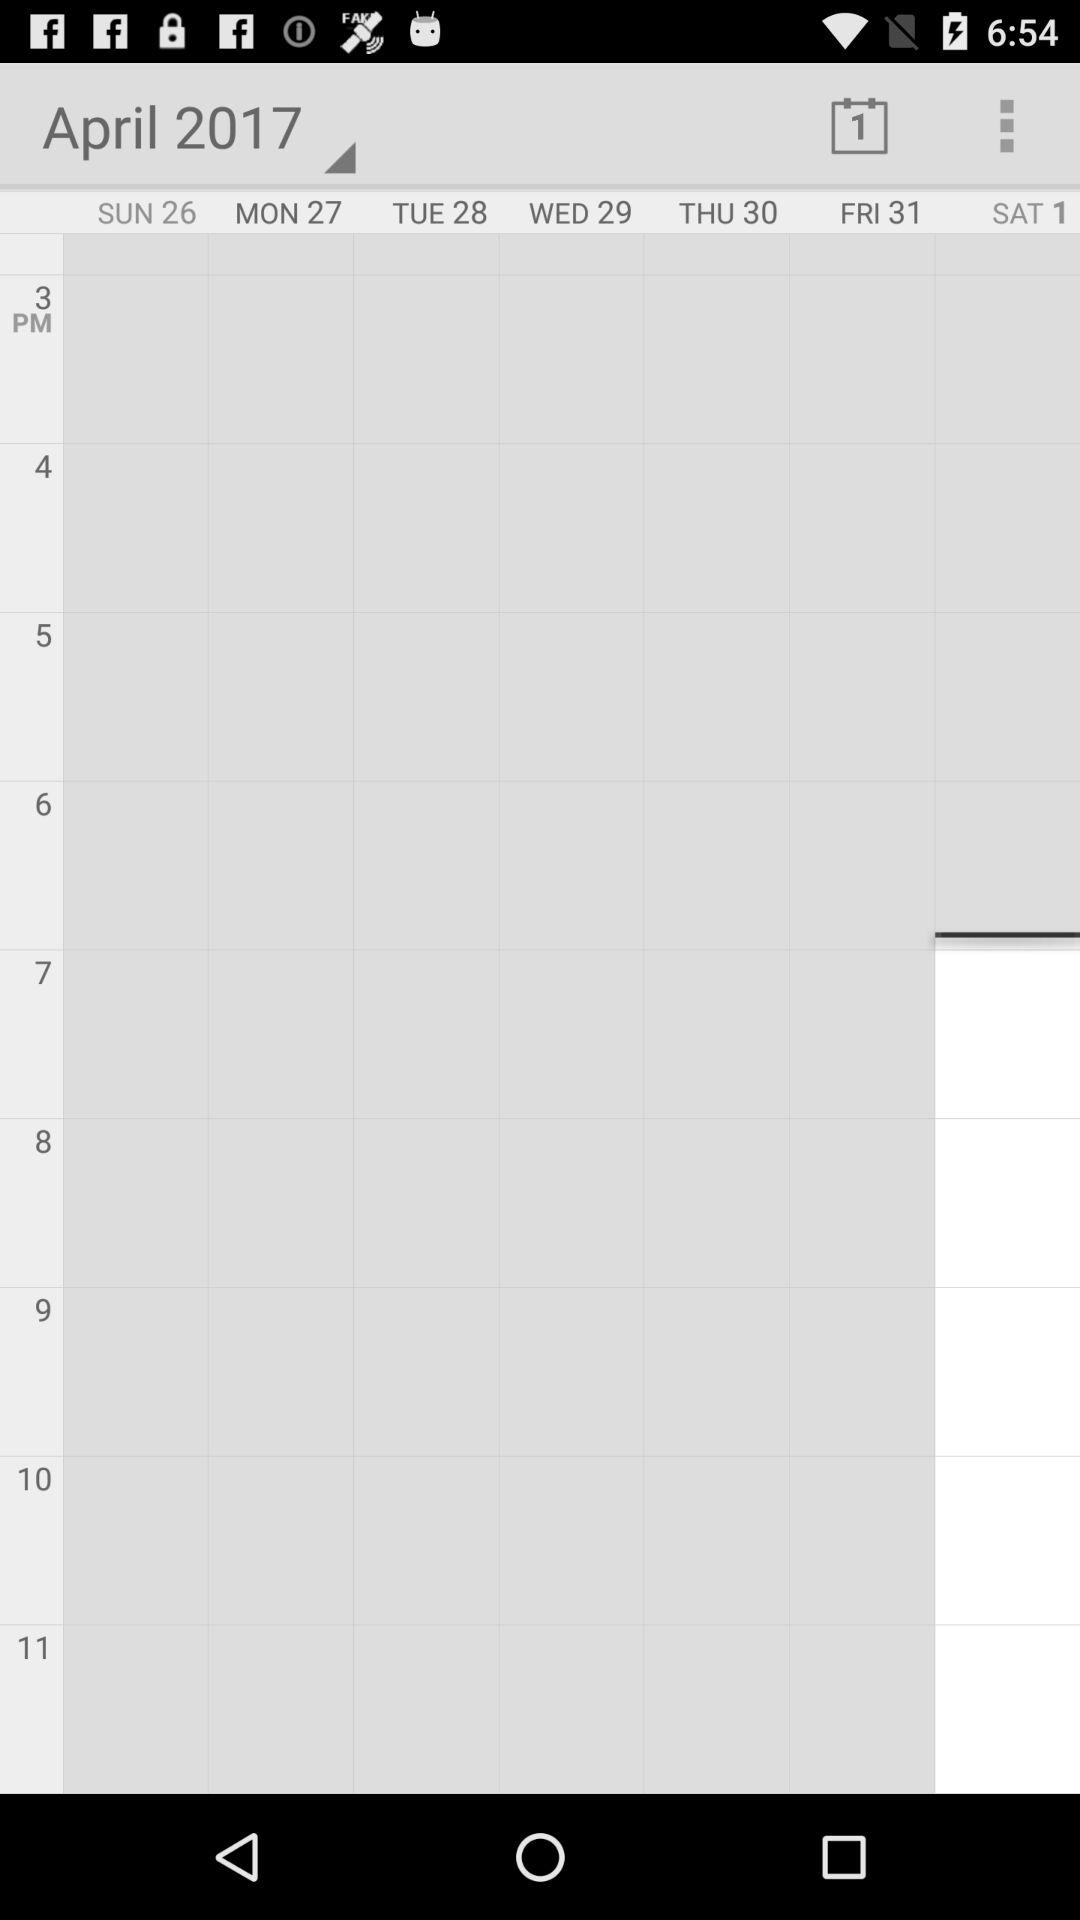Which day is April 27? The day is Monday. 